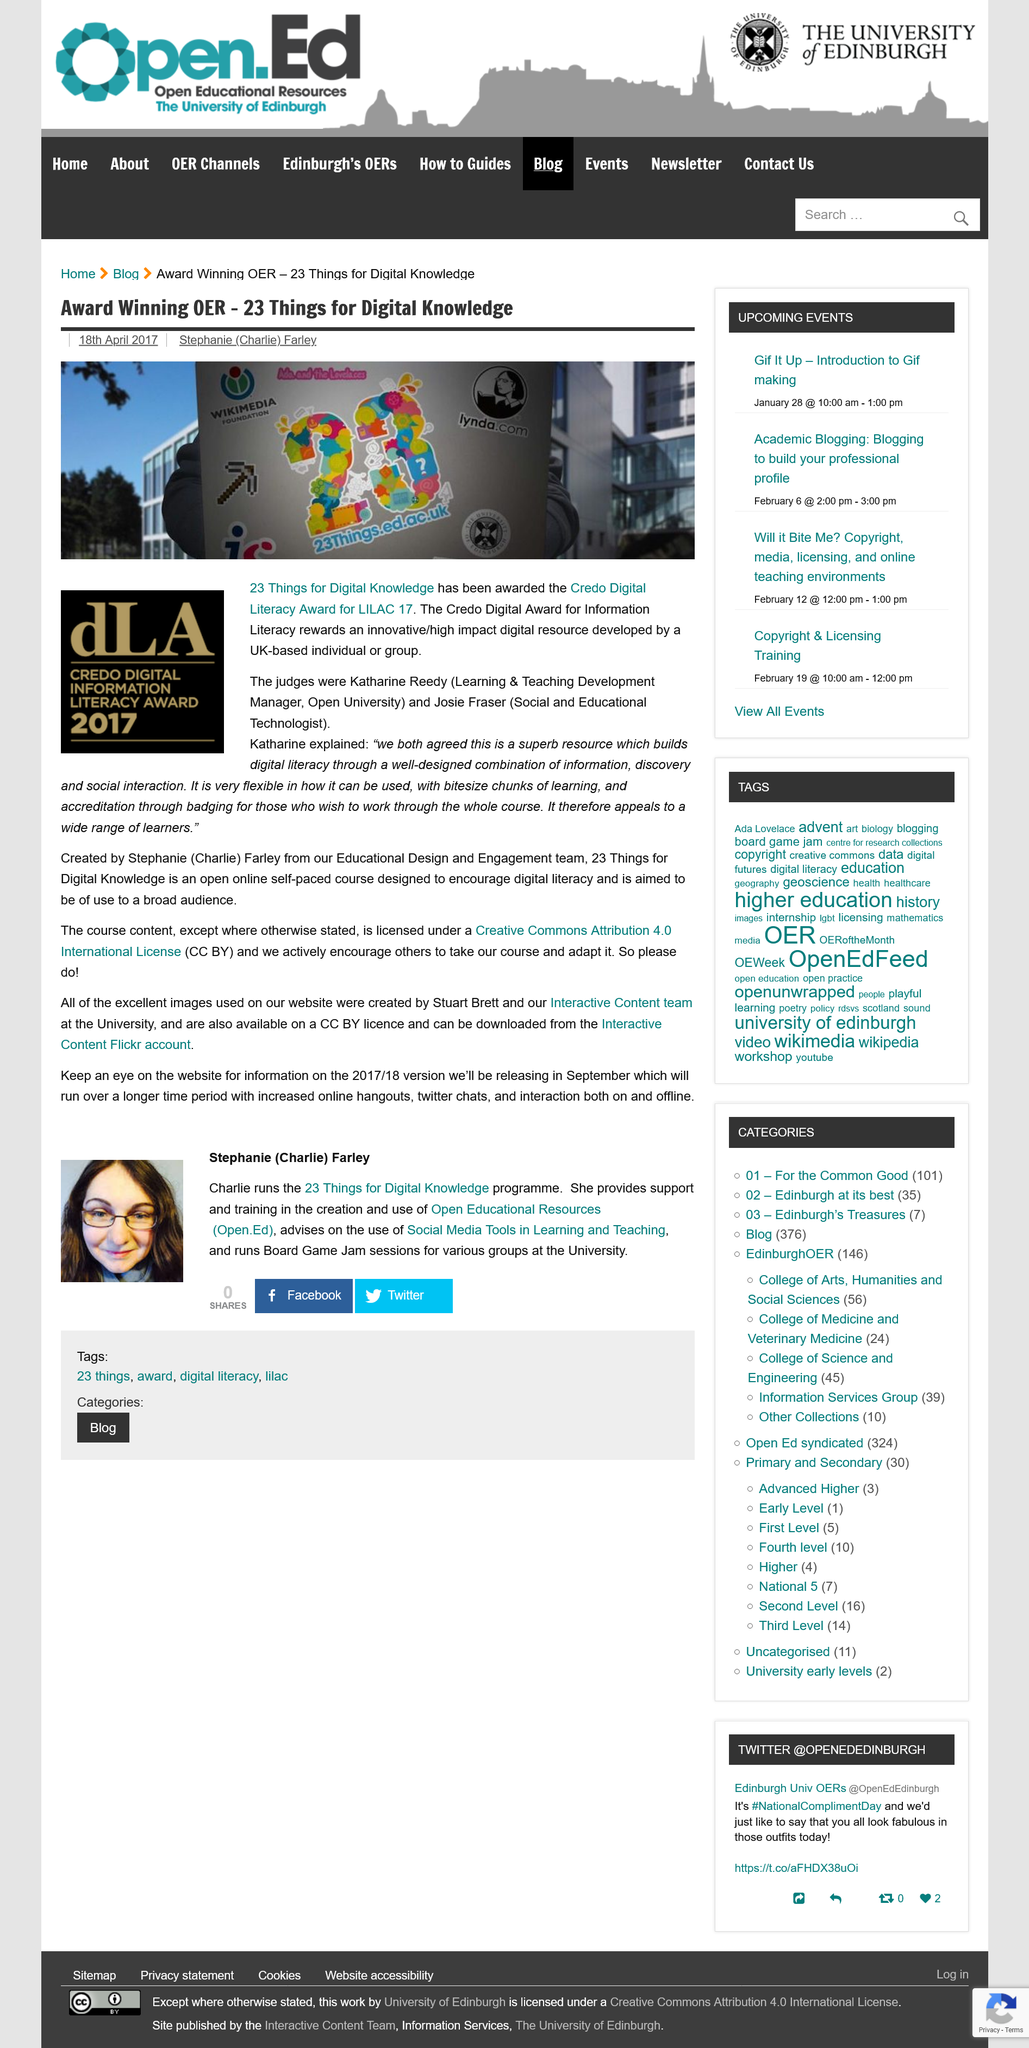Identify some key points in this picture. Charlie Farley, the program director, runs the successful 23 Things for Digital Knowledge program. Stuart Brett, along with the Interactive Content team at the University, created the images on the website. 23 Things for Digital Knowledge has been awarded the Credo Digital Literacy Award for LILAC 17 by Who. The judges of the Credo Digital Literacy Award for LILAC 17 were Katharine Reedy and Josie Fraser. 23 Things for Digital Knowledge is an open online self-paced course designed to encourage digital literacy and is intended for a broad audience. 